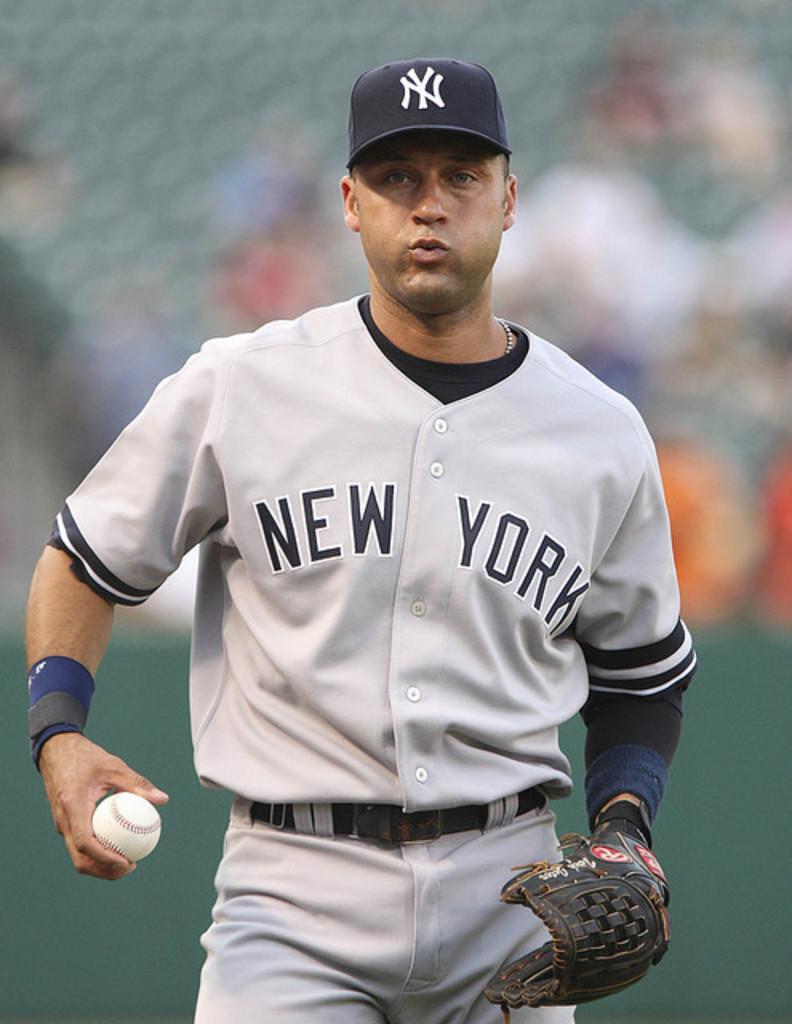What baseball team does he play for?
Keep it short and to the point. New york. What initials are on the players hat?
Your answer should be very brief. Ny. 